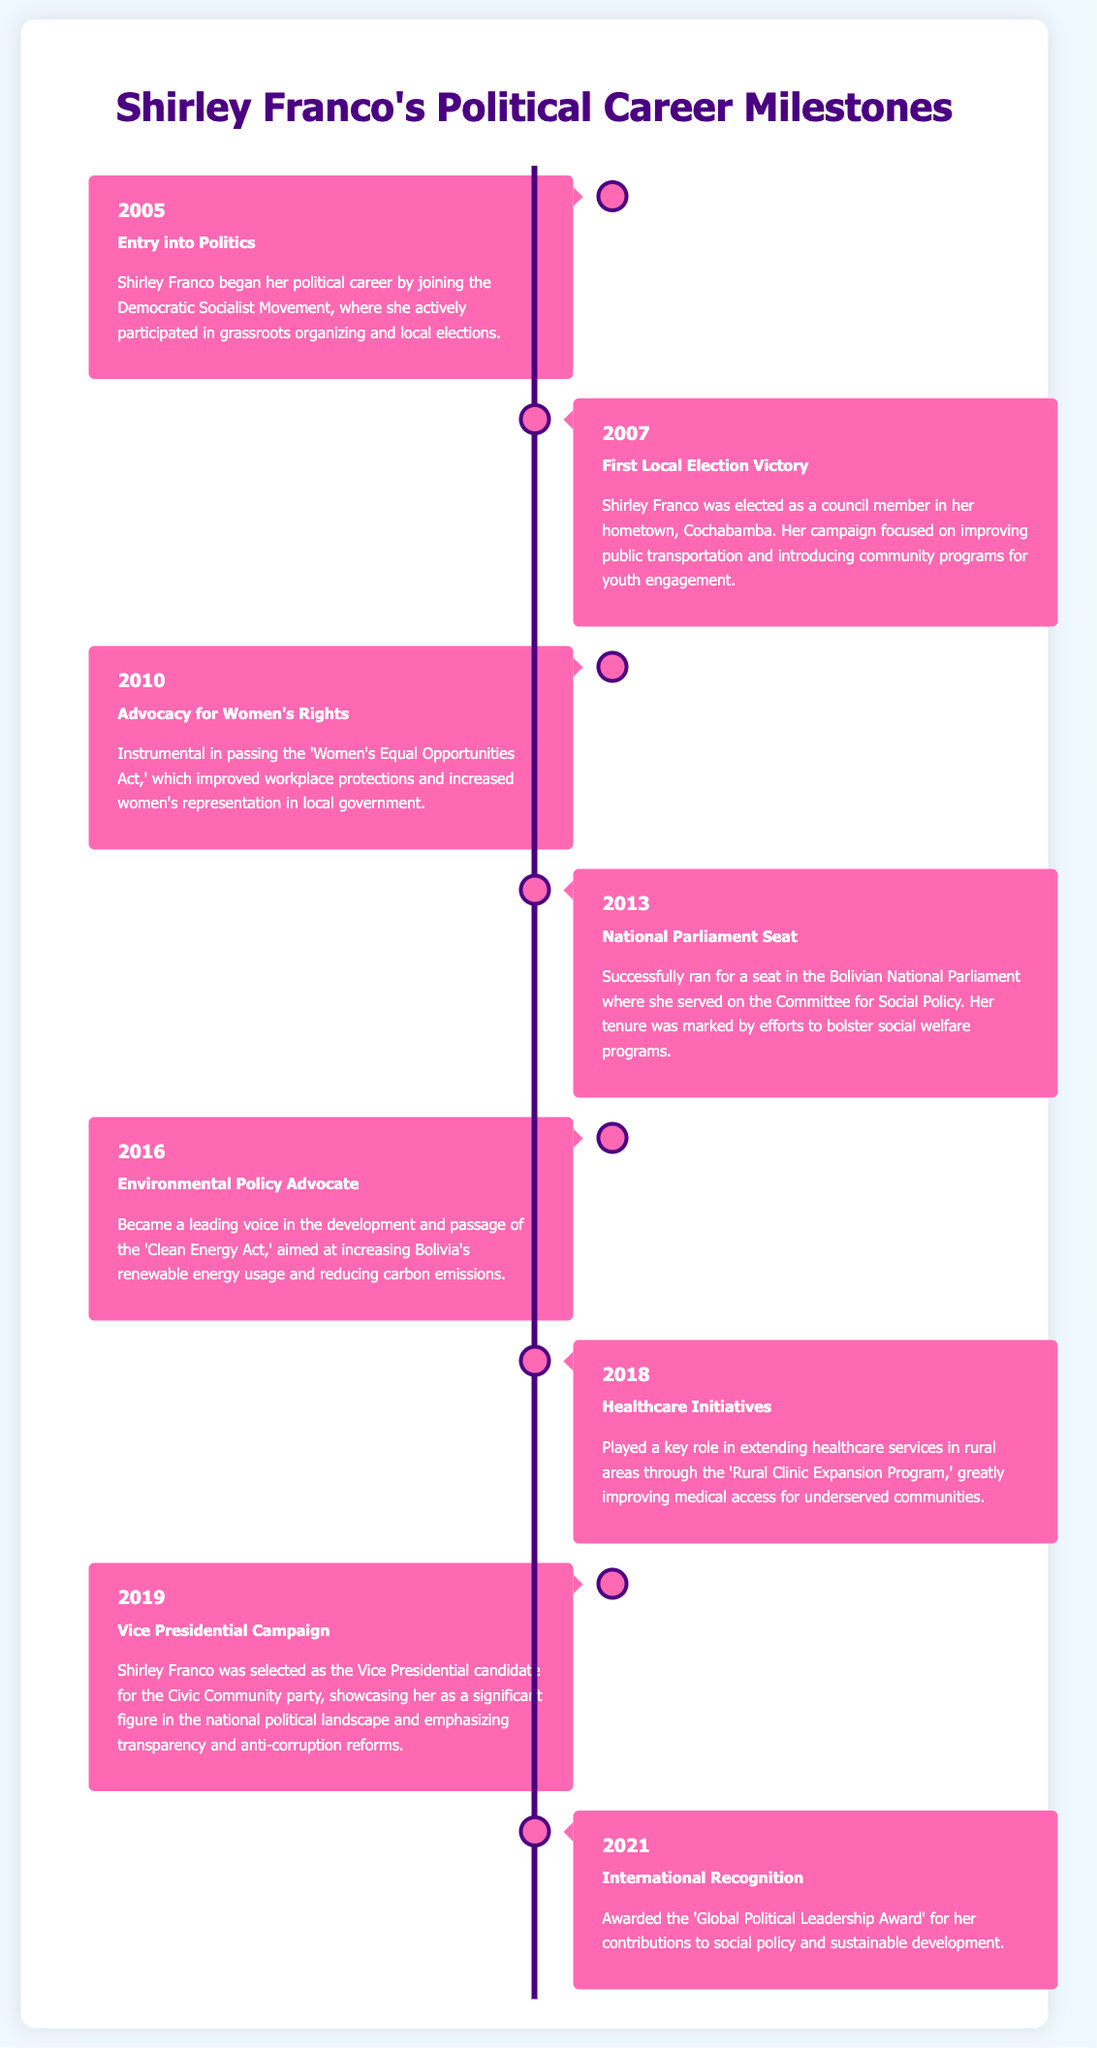What year did Shirley Franco enter politics? The document states that Shirley Franco began her political career in 2005.
Answer: 2005 What major act did Shirley Franco advocate for in 2010? The document highlights her instrumental role in passing the 'Women's Equal Opportunities Act' in 2010.
Answer: 'Women's Equal Opportunities Act' In which year did Shirley Franco achieve national recognition? The infographic notes that she was awarded the 'Global Political Leadership Award' in 2021.
Answer: 2021 What was Shirley Franco's role in the 2019 election? According to the document, she was selected as the Vice Presidential candidate for the Civic Community party in 2019.
Answer: Vice Presidential candidate Which environmental legislation did Shirley Franco help develop in 2016? The document mentions her advocacy for the 'Clean Energy Act' in 2016.
Answer: 'Clean Energy Act' Which position did Shirley Franco hold after her election in 2007? Post her election, she served as a council member in her hometown, Cochabamba.
Answer: Council member What issue was a focus of her campaign in the 2007 local election? The document states that her campaign focused on improving public transportation.
Answer: Public transportation How many years did it take for Shirley Franco to go from her first local election victory to winning a national parliament seat? The timeline indicates her victory in 2007 and her parliamentary seat in 2013, totaling six years.
Answer: 6 years 